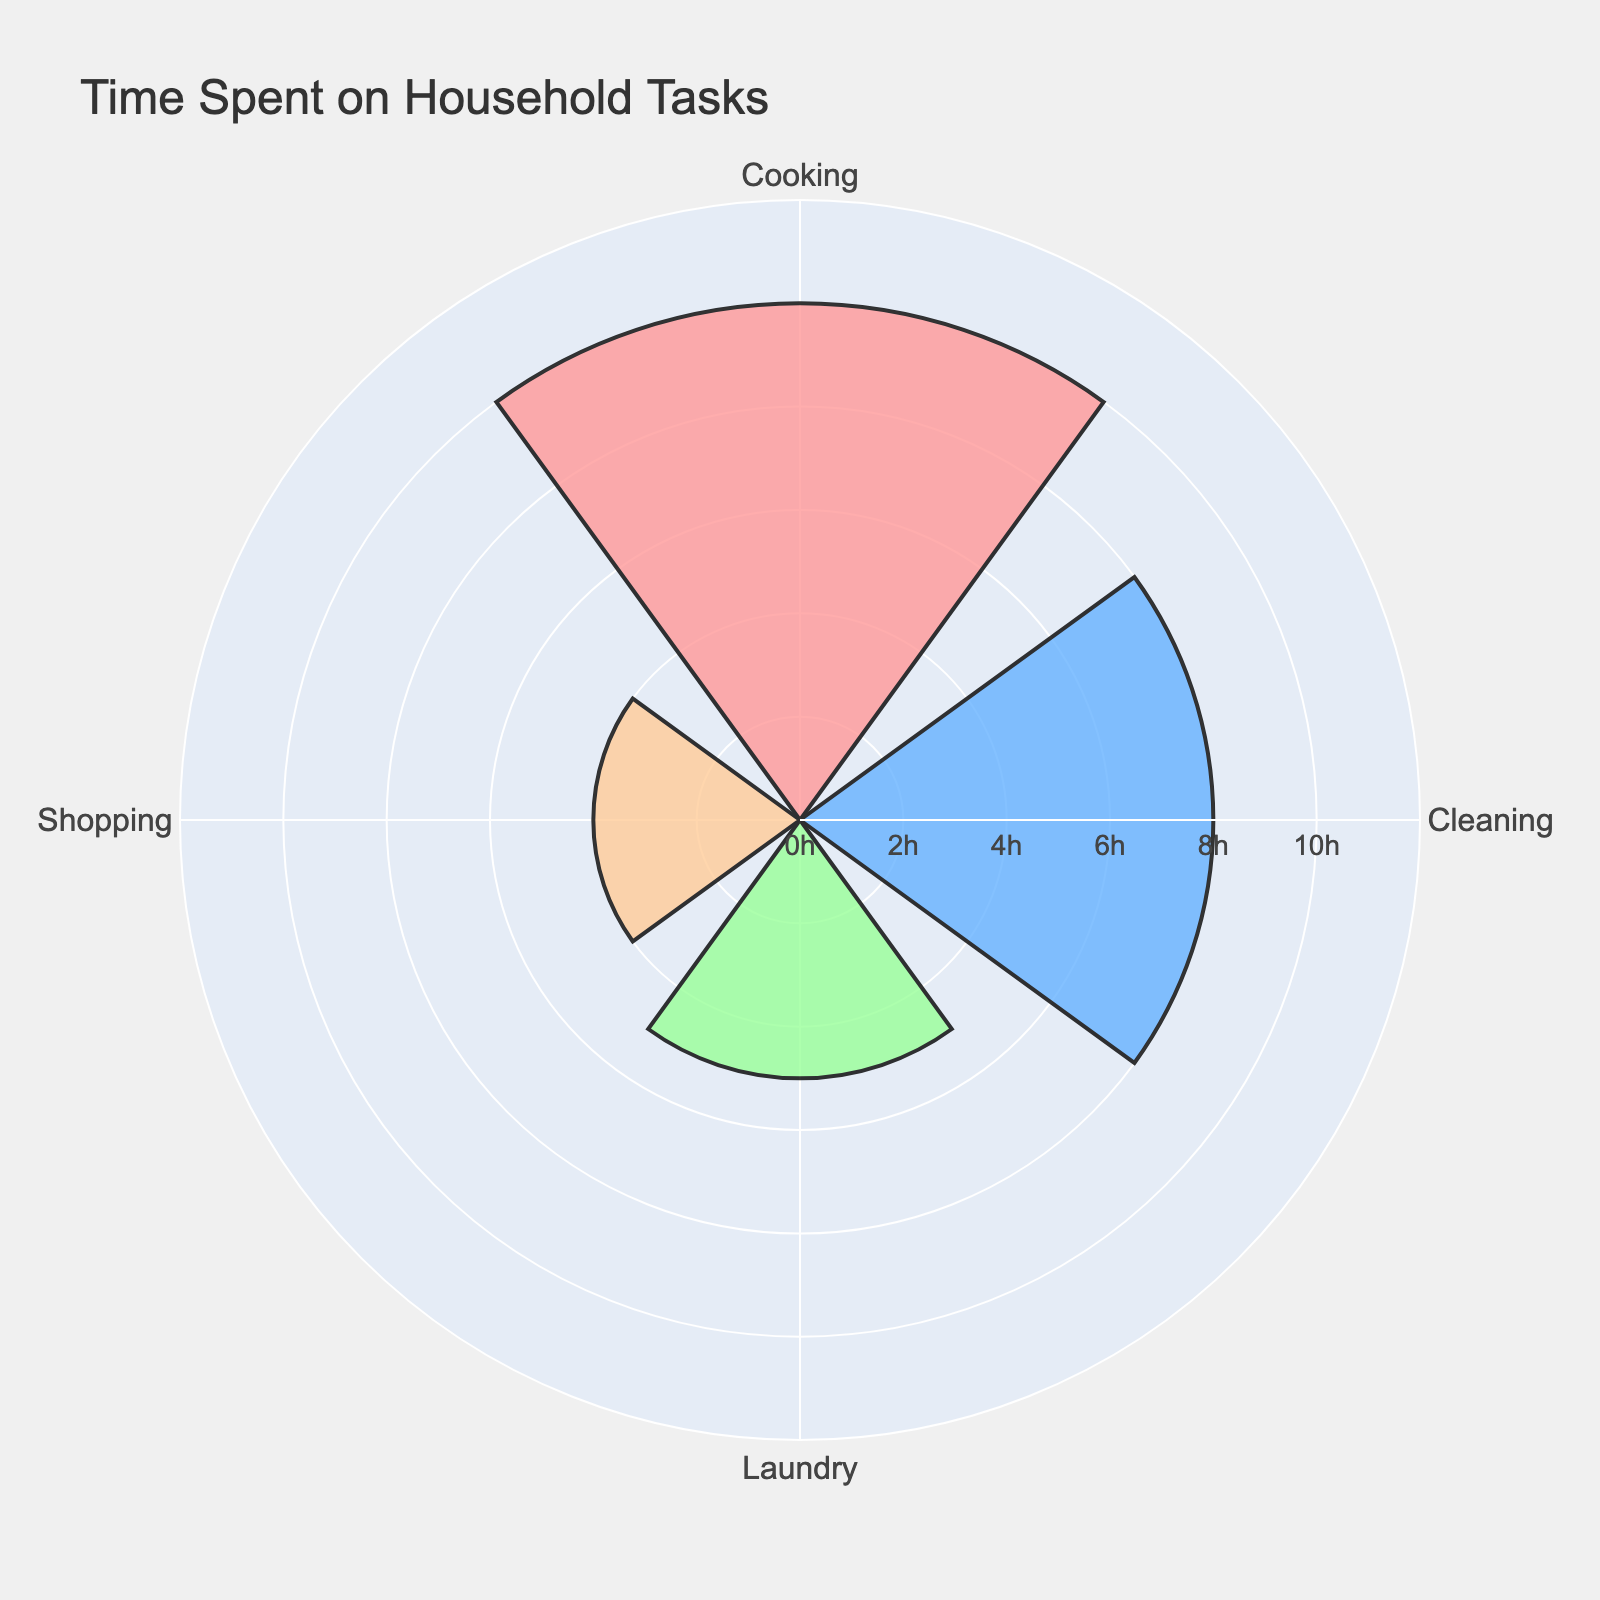What is the total time spent on household tasks per week? To find the total time, add the time spent on each task: Cooking (10 hours), Cleaning (8 hours), Laundry (5 hours), and Shopping (4 hours). So, 10 + 8 + 5 + 4 = 27 hours.
Answer: 27 hours Which task takes the most time? By visually checking the length of the bars, Cooking has the longest bar corresponding to the highest value of 10 hours.
Answer: Cooking How much more time do you spend on cleaning than shopping? Compare the time spent on Cleaning (8 hours) and Shopping (4 hours). The difference is 8 - 4 = 4 hours.
Answer: 4 hours Is the time spent on cooking and cleaning greater than the time spent on laundry and shopping combined? Add the time for Cooking (10) and Cleaning (8): 10 + 8 = 18 hours. Then add the time for Laundry (5) and Shopping (4): 5 + 4 = 9 hours. Compare 18 with 9. 18 is greater than 9.
Answer: Yes What percentage of the total time is spent on laundry? Calculate the total time spent on all tasks (27 hours). The time spent on Laundry is 5 hours. The percentage is (5 / 27) * 100 ≈ 18.52%.
Answer: 18.52% If you had to cut down shopping time by half and allocate this time to cleaning, how much time would be spent on cleaning? Current Shopping time is 4 hours. Half of it is 2 hours. Adding this to the current Cleaning time (8 hours): 8 + 2 = 10 hours.
Answer: 10 hours What's the average time spent per task? There are 4 tasks. Total time is 27 hours. The average is 27 / 4 = 6.75 hours per task.
Answer: 6.75 hours How much more time is spent on cooking than on laundry? Time spent on Cooking is 10 hours, and on Laundry 5 hours. The difference is 10 - 5 = 5 hours.
Answer: 5 hours Which task has the second least time spent? By visually checking the bars, the second smallest bar corresponds to Laundry with 5 hours.
Answer: Laundry 